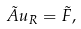Convert formula to latex. <formula><loc_0><loc_0><loc_500><loc_500>\tilde { A } u _ { R } = \tilde { F } ,</formula> 